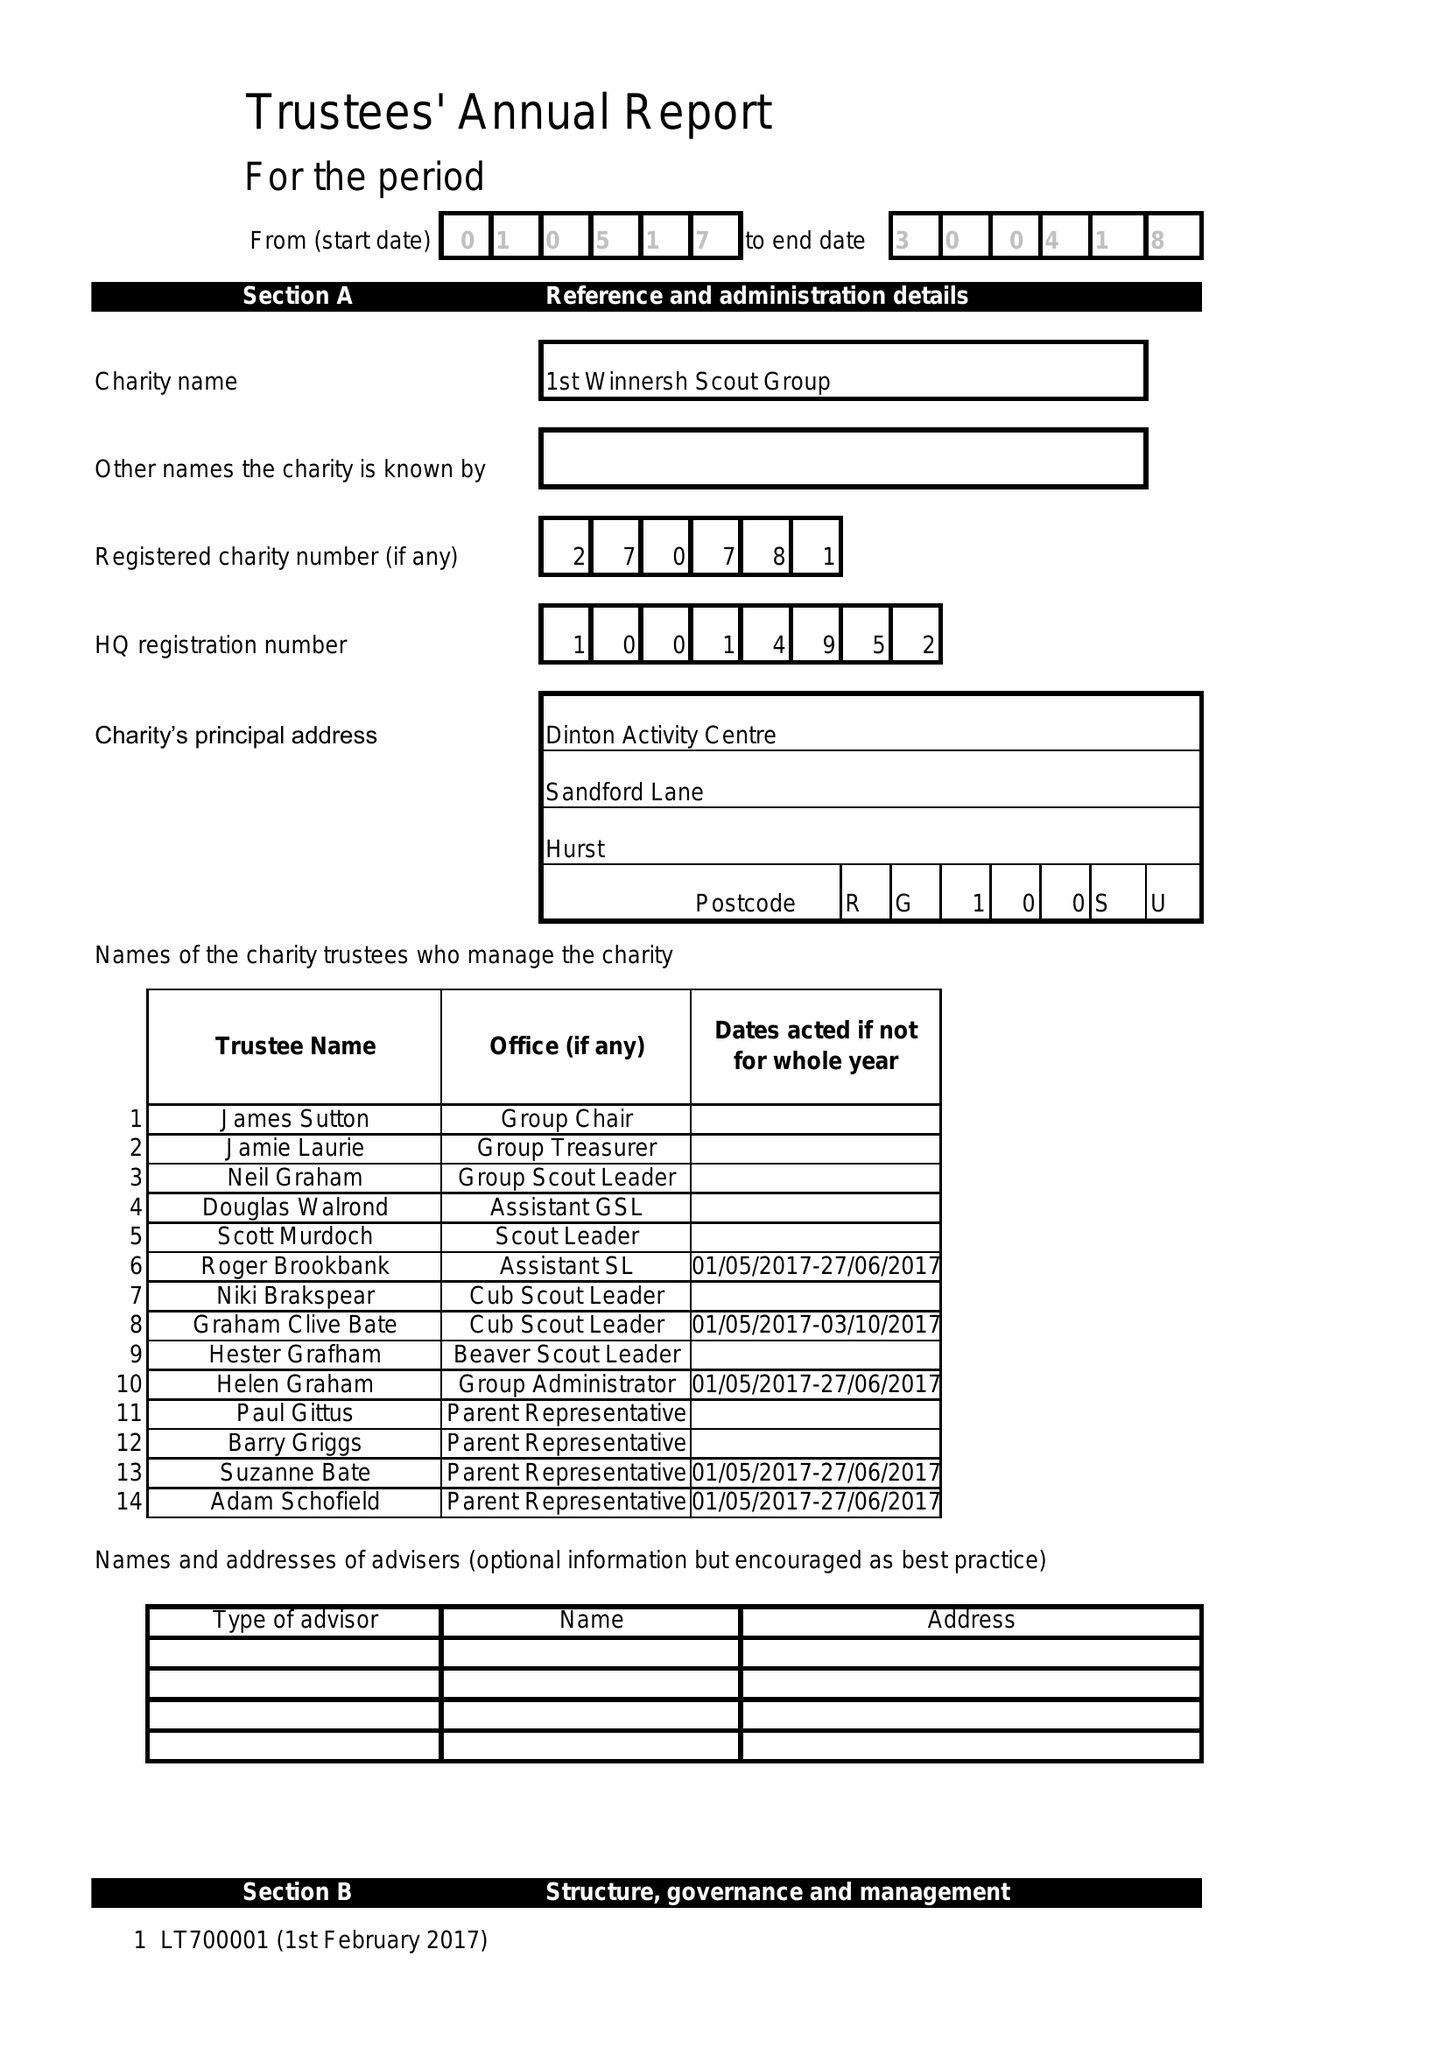What is the value for the spending_annually_in_british_pounds?
Answer the question using a single word or phrase. 26043.33 